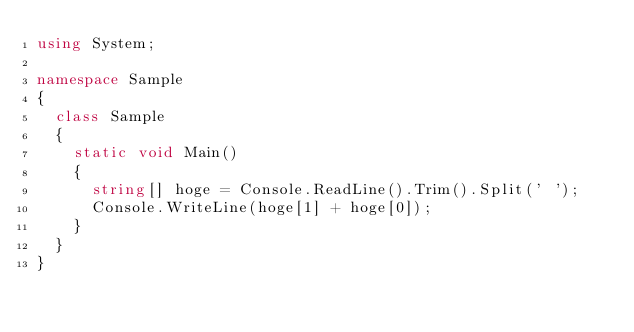Convert code to text. <code><loc_0><loc_0><loc_500><loc_500><_C#_>using System;
 
namespace Sample
{
  class Sample
  {
    static void Main()
    {
      string[] hoge = Console.ReadLine().Trim().Split(' ');
      Console.WriteLine(hoge[1] + hoge[0]);
    }
  }
}</code> 